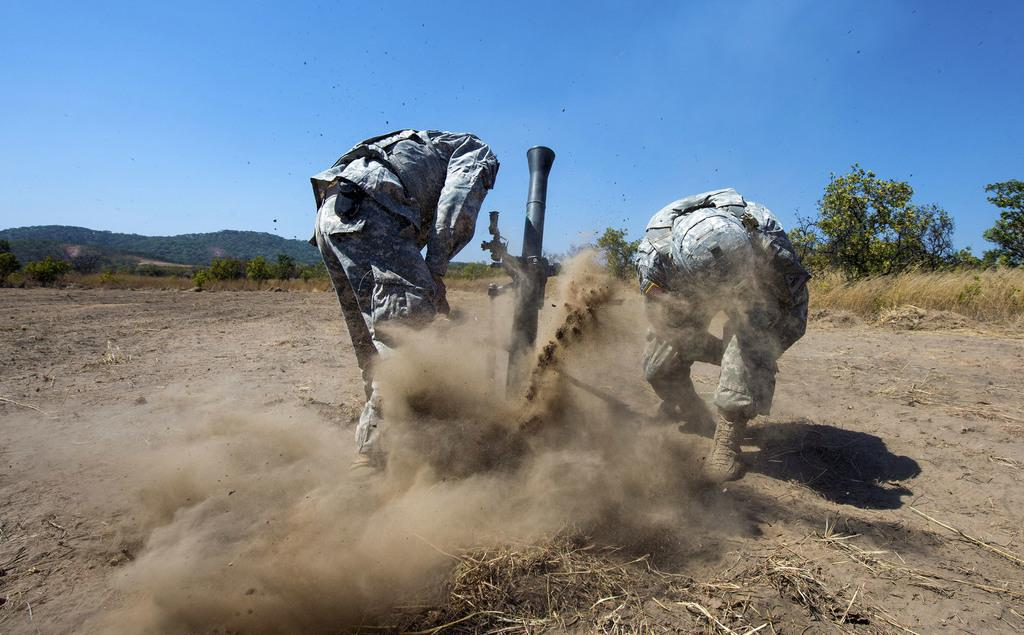How many people are present in the image? There are two people in the image. What can be seen in the image besides the people? There is a weapon, the ground, grass, trees, hills, and the sky visible in the image. What type of terrain is visible in the image? The image shows grass, trees, and hills, indicating a natural, outdoor setting. What is the condition of the sky in the image? The sky is visible in the background of the image. What type of record can be heard playing in the background of the image? There is no record playing in the background of the image, as it is a still image and does not contain any audible elements. 